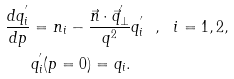Convert formula to latex. <formula><loc_0><loc_0><loc_500><loc_500>\frac { d q _ { i } ^ { ^ { \prime } } } { d p } & = n _ { i } - \frac { \vec { n } \cdot \vec { q } _ { \bot } ^ { ^ { \prime } } } { q ^ { 2 } } q _ { i } ^ { ^ { \prime } } \ \ , \ \ i = 1 , 2 , \\ & q _ { i } ^ { ^ { \prime } } ( p = 0 ) = q _ { i } .</formula> 